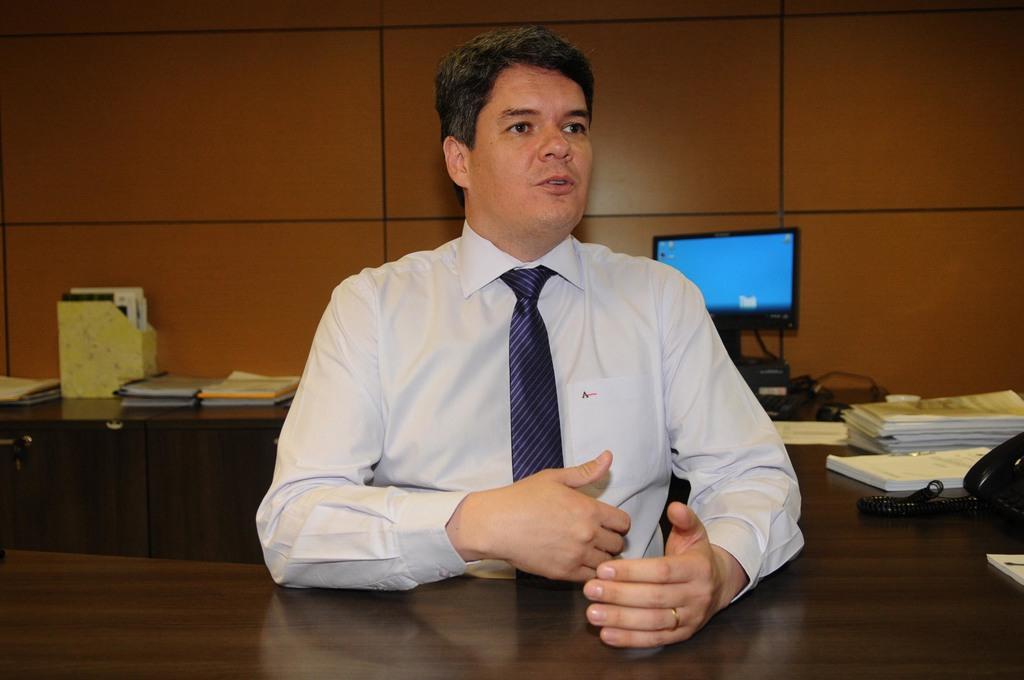Can you describe this image briefly? There is a man in white color shirt, wearing a tie, sitting and talking. In front of him, there is a wooden table. In the background, there is monitor, books, telephone on the table, a wall which is in brown color and some other materials on the table. 